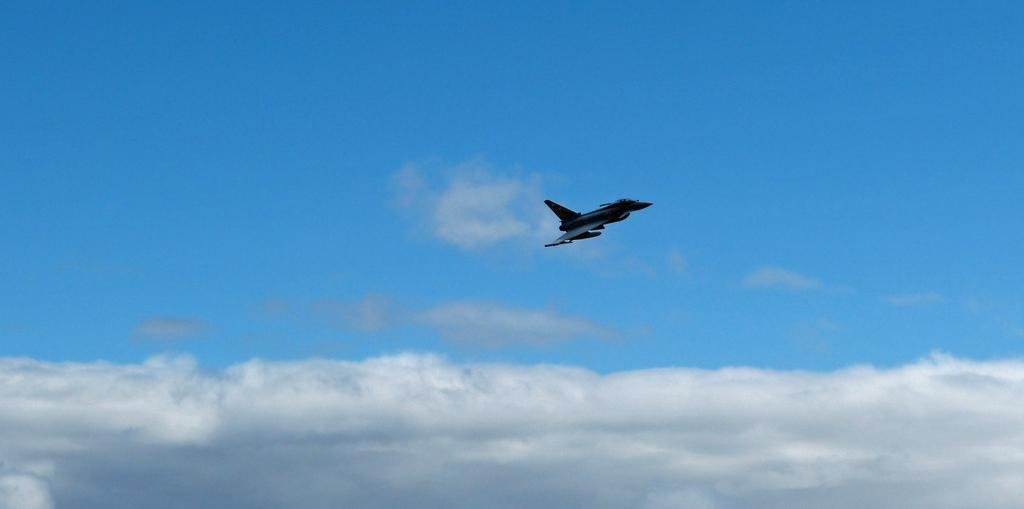What is the main subject of the image? The main subject of the image is an aircraft flying. What can be seen in the background of the image? The sky is visible at the top of the image. What is present at the bottom of the image? Clouds are present at the bottom of the image. What is the value of the page in the image? There is no page present in the image, so it is not possible to determine its value. 